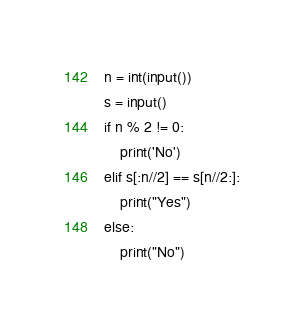<code> <loc_0><loc_0><loc_500><loc_500><_Python_>n = int(input())
s = input()
if n % 2 != 0:
    print('No')
elif s[:n//2] == s[n//2:]:
    print("Yes")
else:
    print("No")
</code> 